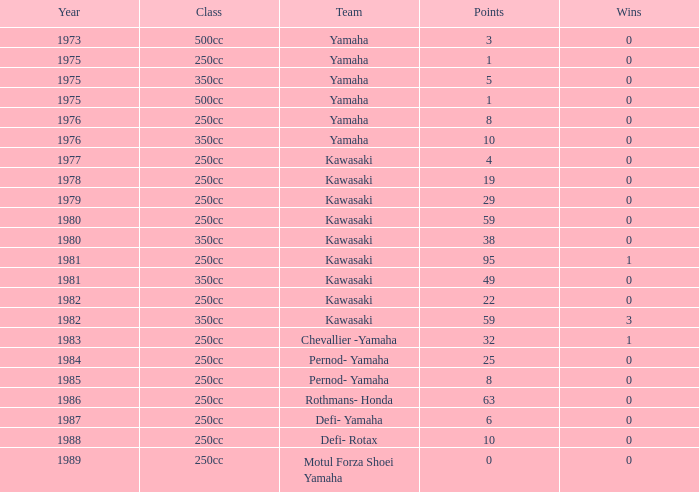What was kawasaki's maximum victory count as a team, with 95 points, and in the year before 1981? None. Help me parse the entirety of this table. {'header': ['Year', 'Class', 'Team', 'Points', 'Wins'], 'rows': [['1973', '500cc', 'Yamaha', '3', '0'], ['1975', '250cc', 'Yamaha', '1', '0'], ['1975', '350cc', 'Yamaha', '5', '0'], ['1975', '500cc', 'Yamaha', '1', '0'], ['1976', '250cc', 'Yamaha', '8', '0'], ['1976', '350cc', 'Yamaha', '10', '0'], ['1977', '250cc', 'Kawasaki', '4', '0'], ['1978', '250cc', 'Kawasaki', '19', '0'], ['1979', '250cc', 'Kawasaki', '29', '0'], ['1980', '250cc', 'Kawasaki', '59', '0'], ['1980', '350cc', 'Kawasaki', '38', '0'], ['1981', '250cc', 'Kawasaki', '95', '1'], ['1981', '350cc', 'Kawasaki', '49', '0'], ['1982', '250cc', 'Kawasaki', '22', '0'], ['1982', '350cc', 'Kawasaki', '59', '3'], ['1983', '250cc', 'Chevallier -Yamaha', '32', '1'], ['1984', '250cc', 'Pernod- Yamaha', '25', '0'], ['1985', '250cc', 'Pernod- Yamaha', '8', '0'], ['1986', '250cc', 'Rothmans- Honda', '63', '0'], ['1987', '250cc', 'Defi- Yamaha', '6', '0'], ['1988', '250cc', 'Defi- Rotax', '10', '0'], ['1989', '250cc', 'Motul Forza Shoei Yamaha', '0', '0']]} 